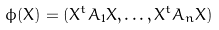<formula> <loc_0><loc_0><loc_500><loc_500>\phi ( X ) = ( X ^ { t } A _ { 1 } X , \dots , X ^ { t } A _ { n } X )</formula> 